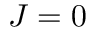Convert formula to latex. <formula><loc_0><loc_0><loc_500><loc_500>J = 0</formula> 